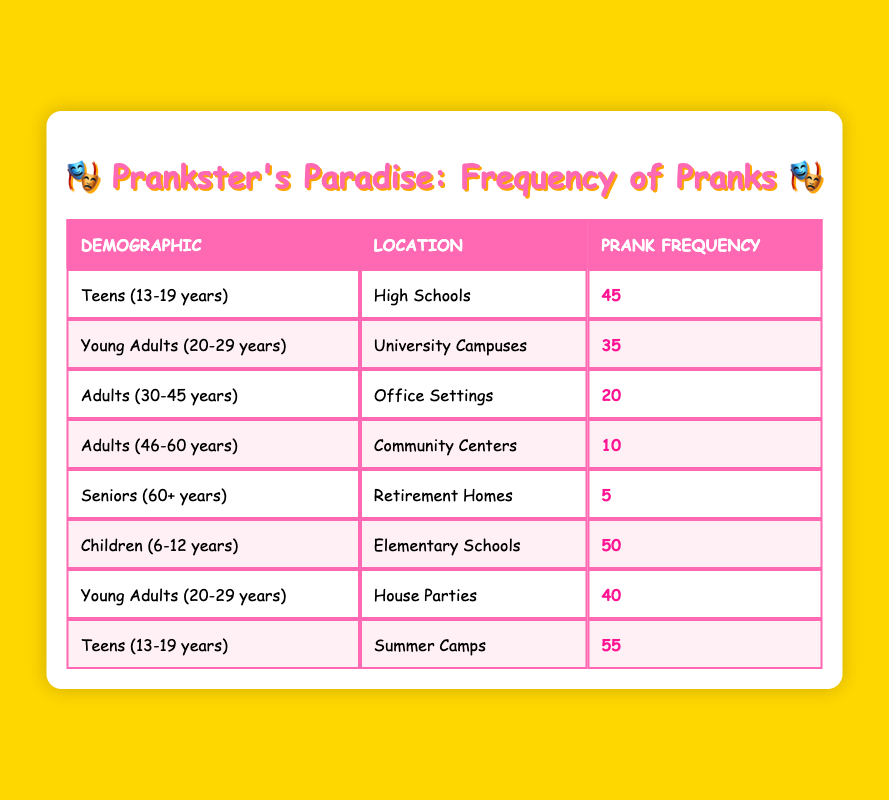What is the prank frequency for Teens in High Schools? The table indicates that the prank frequency for the demographic of Teens (13-19 years) in High Schools is 45.
Answer: 45 Which location has the highest prank frequency among Children? Children (6-12 years) execute pranks the most frequently in Elementary Schools, as indicated by the table, with a frequency of 50.
Answer: 50 Is it true that Seniors have a higher prank frequency than Adults aged 30-45? The table shows that Seniors (60+ years) have a prank frequency of 5, while Adults (30-45 years) have a frequency of 20. Therefore, it is false that Seniors have a higher frequency.
Answer: No What is the total prank frequency for Young Adults (20-29 years) across all locations? The prank frequency for Young Adults (20-29 years) is 35 in University Campuses and 40 in House Parties. Adding these together gives 35 + 40 = 75.
Answer: 75 What is the average prank frequency of Adults (30-45 years) and Seniors (60+ years)? The prank frequency for Adults (30-45 years) is 20 and for Seniors (60+ years) is 5. To find the average, we add them (20 + 5 = 25) and then divide by the number of groups, which is 2. So, the average is 25 / 2 = 12.5.
Answer: 12.5 Among all demographics, which group has the lowest prank frequency? Referring to the table, Seniors (60+ years) have the lowest prank frequency at 5, lower than any other demographic or location listed.
Answer: 5 Which demographic executed more pranks: Teens at Summer Camps or Children at Elementary Schools? Teens (13-19 years) at Summer Camps have a prank frequency of 55, while Children (6-12 years) at Elementary Schools have a frequency of 50. Comparing these two values, Teens at Summer Camps executed more pranks.
Answer: Teens at Summer Camps What is the difference in prank frequency between Young Adults (20-29 years) at House Parties and Adults (46-60 years) at Community Centers? The prank frequency for Young Adults (20-29 years) at House Parties is 40, while for Adults (46-60 years) at Community Centers, it is 10. The difference is calculated by subtracting the lower frequency from the higher frequency: 40 - 10 = 30.
Answer: 30 How many demographics have a prank frequency of 40 or higher? Examining the table, we find that the demographics with a prank frequency of 40 or higher are Teens (13-19 years) in High Schools (45), Teens in Summer Camps (55), Children (6-12 years) in Elementary Schools (50), Young Adults (20-29 years) at House Parties (40), and Young Adults (20-29 years) in University Campuses (35). This gives a total of four demographics.
Answer: 4 